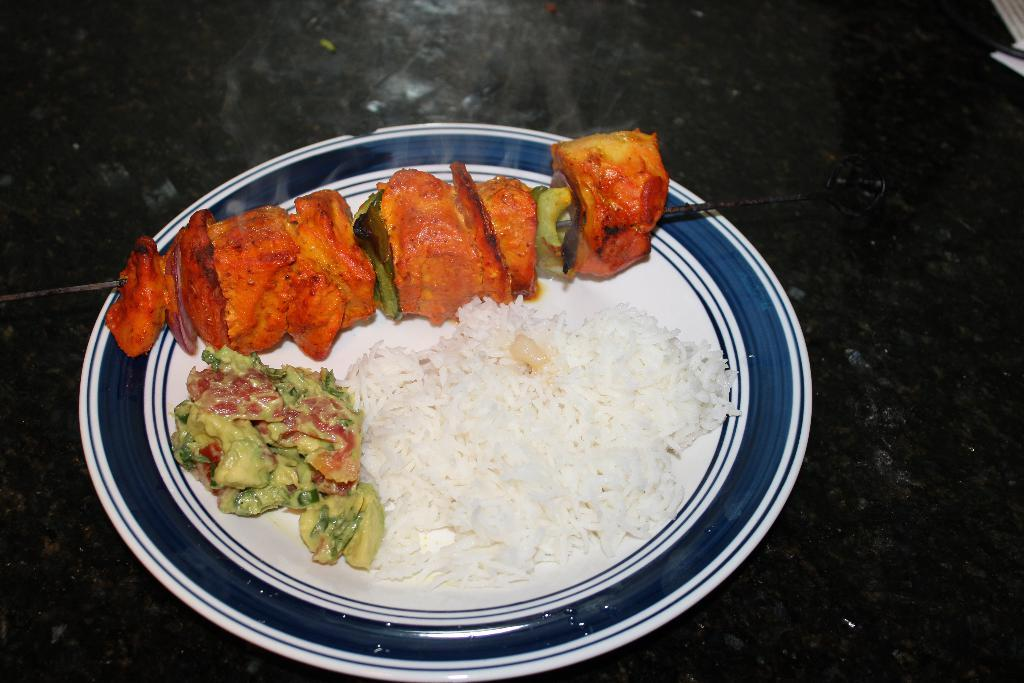What is on the plate that is visible in the image? The plate contains rice and curry, which is yellow in color. What type of food is on the stick beside the plate? There is roasted meat on a stick beside the plate. What is the weather like in the image? The provided facts do not mention any information about the weather, so it cannot be determined from the image. 